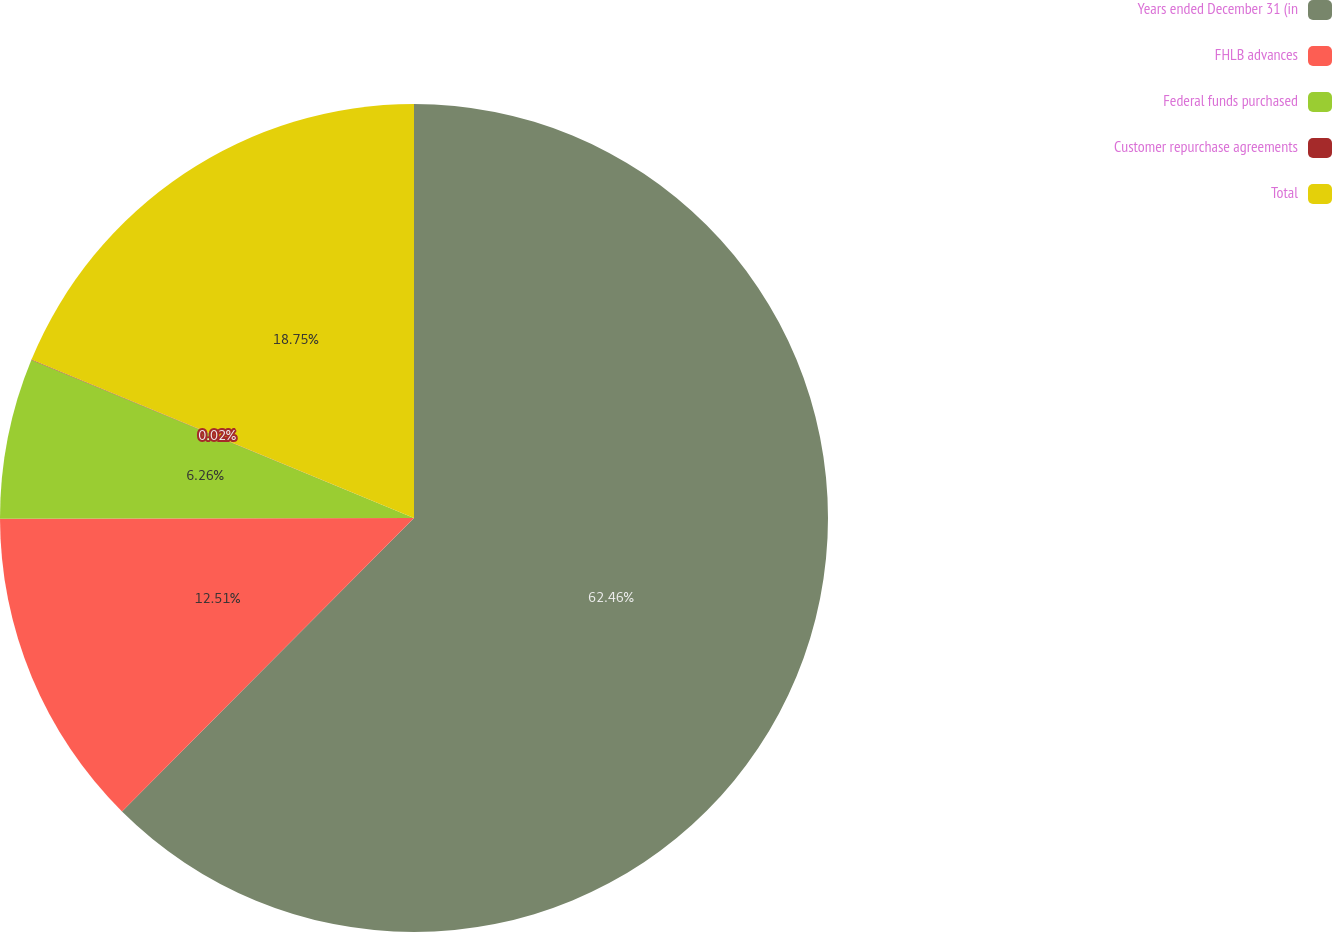Convert chart. <chart><loc_0><loc_0><loc_500><loc_500><pie_chart><fcel>Years ended December 31 (in<fcel>FHLB advances<fcel>Federal funds purchased<fcel>Customer repurchase agreements<fcel>Total<nl><fcel>62.46%<fcel>12.51%<fcel>6.26%<fcel>0.02%<fcel>18.75%<nl></chart> 